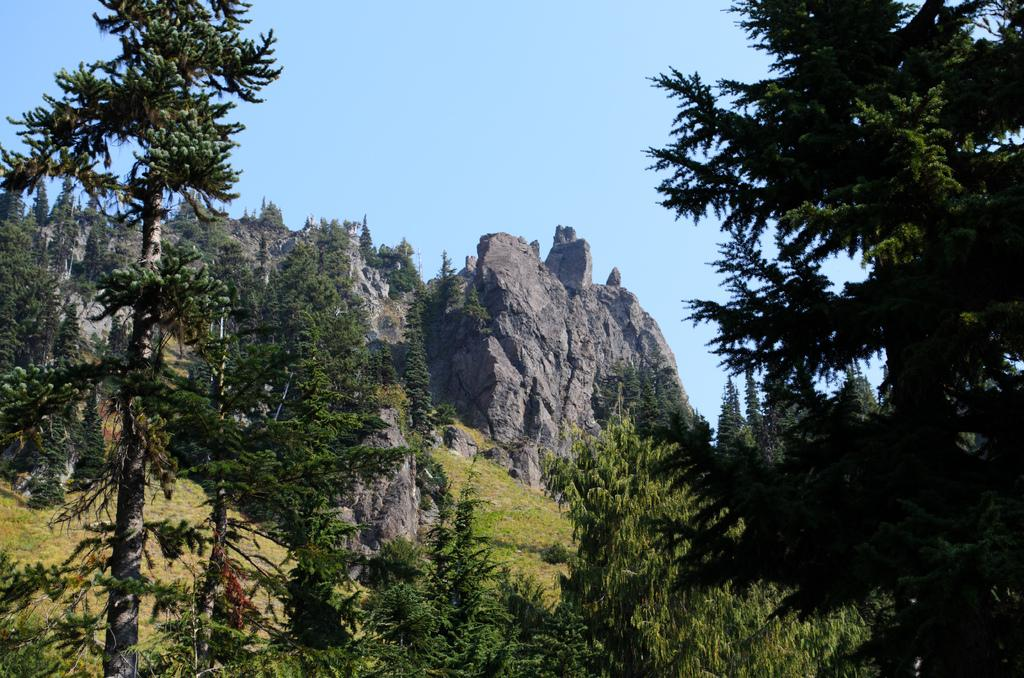What type of vegetation can be seen in the image? There are trees in the image. What can be seen on the hill in the background? There is grass on a hill in the background. What type of geographical feature is visible in the background? There are rocky mountains in the background. What else is present in the background of the image? There are trees in the background. What is visible at the top of the image? The sky is visible at the top of the image. Is there any smoke coming from the trees in the image? There is no smoke present in the image; only trees, grass, rocky mountains, and the sky are visible. What type of drain is visible in the image? There is no drain present in the image. 